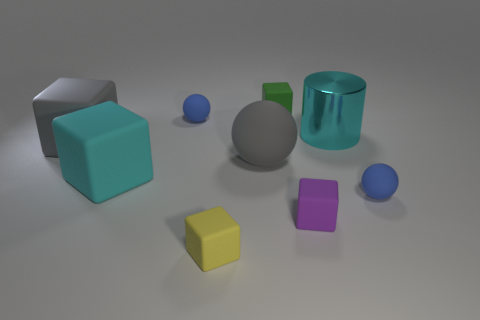Subtract all gray cubes. How many cubes are left? 4 Subtract all green cubes. How many cubes are left? 4 Subtract all blue cubes. Subtract all red spheres. How many cubes are left? 5 Add 1 shiny cylinders. How many objects exist? 10 Subtract all spheres. How many objects are left? 6 Subtract all big cyan matte things. Subtract all tiny yellow things. How many objects are left? 7 Add 9 large cyan cylinders. How many large cyan cylinders are left? 10 Add 6 small red matte cubes. How many small red matte cubes exist? 6 Subtract 0 red cylinders. How many objects are left? 9 